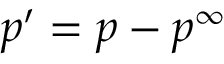Convert formula to latex. <formula><loc_0><loc_0><loc_500><loc_500>p ^ { \prime } = p - p ^ { \infty }</formula> 